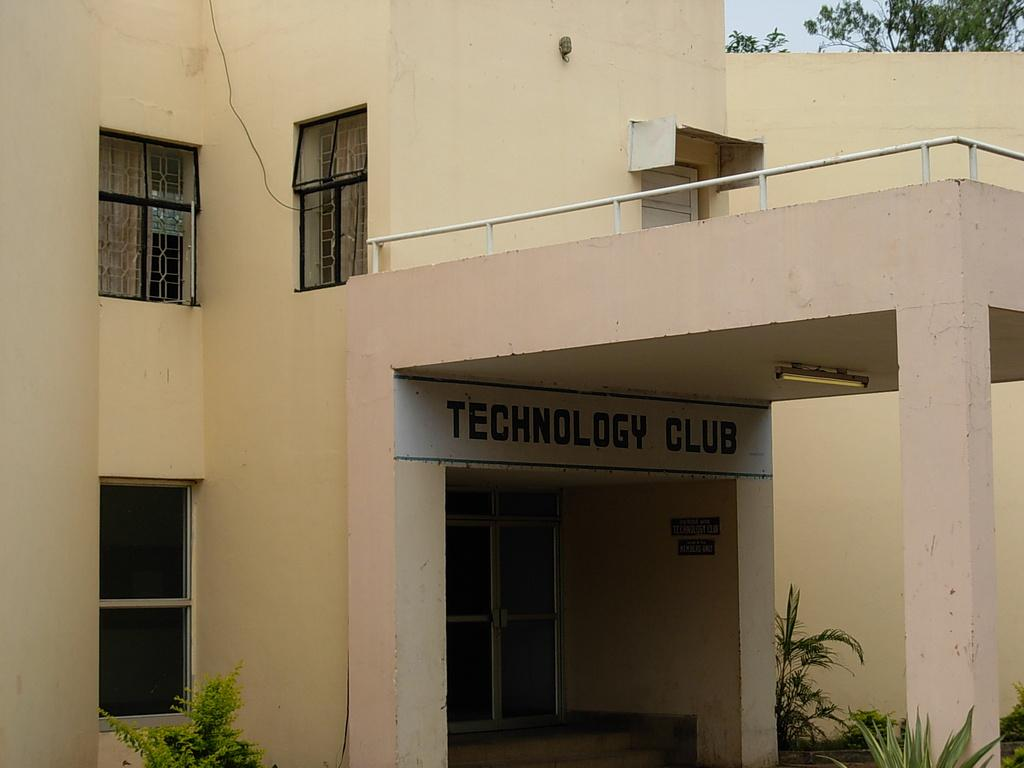What type of structure is present in the image? There is a building in the image. Can you describe the color of the building? The building is in cream color. What feature can be seen on the building? There are glass windows on the building. What is the color of the trees in the image? The trees in the image are green. How would you describe the sky in the background? The sky in the background is white. Where are the bears sitting on the sofa in the image? There are no bears or sofa present in the image. 